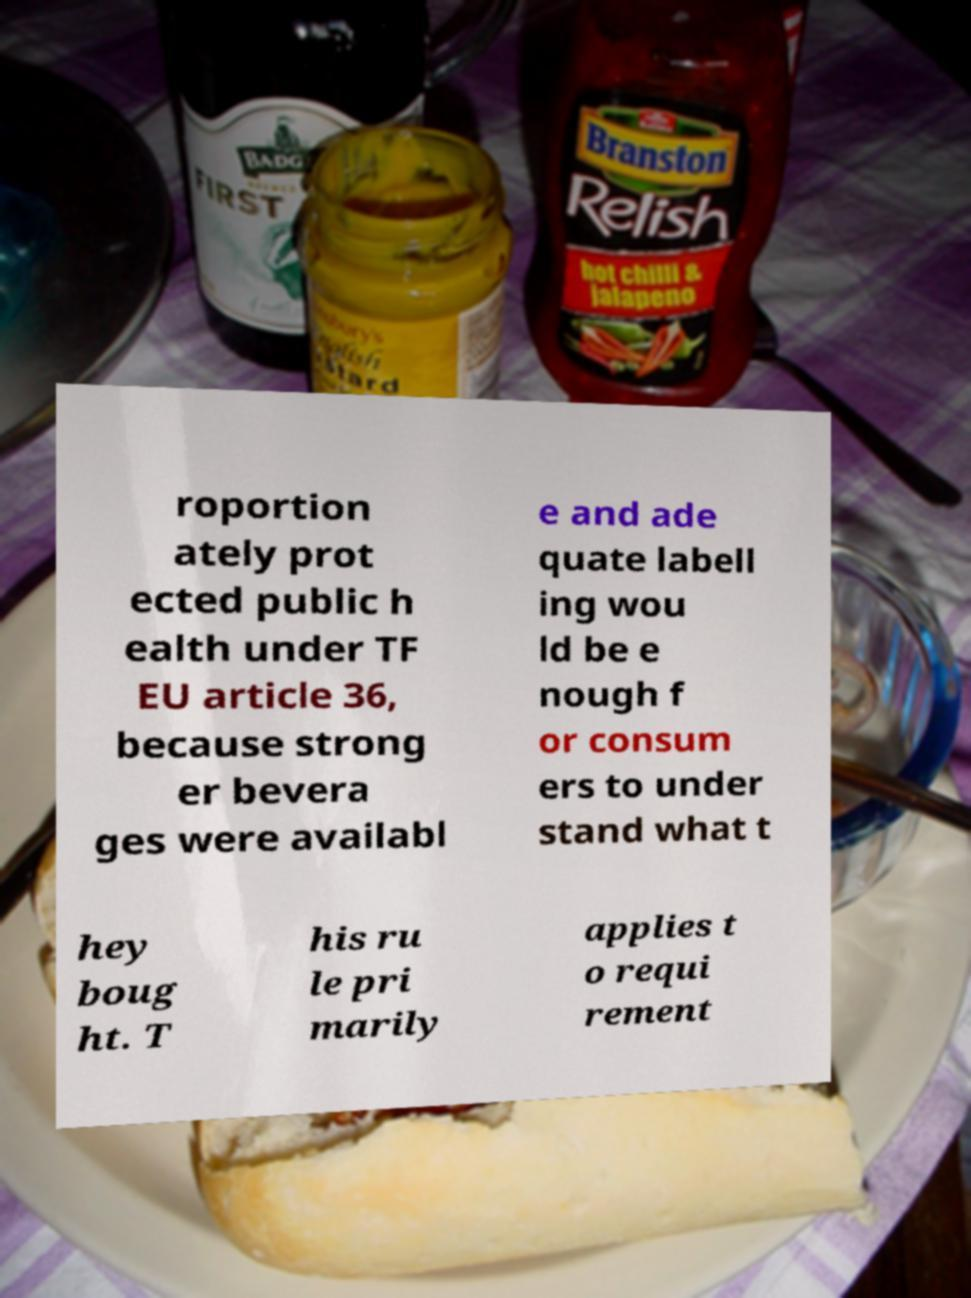Please read and relay the text visible in this image. What does it say? roportion ately prot ected public h ealth under TF EU article 36, because strong er bevera ges were availabl e and ade quate labell ing wou ld be e nough f or consum ers to under stand what t hey boug ht. T his ru le pri marily applies t o requi rement 